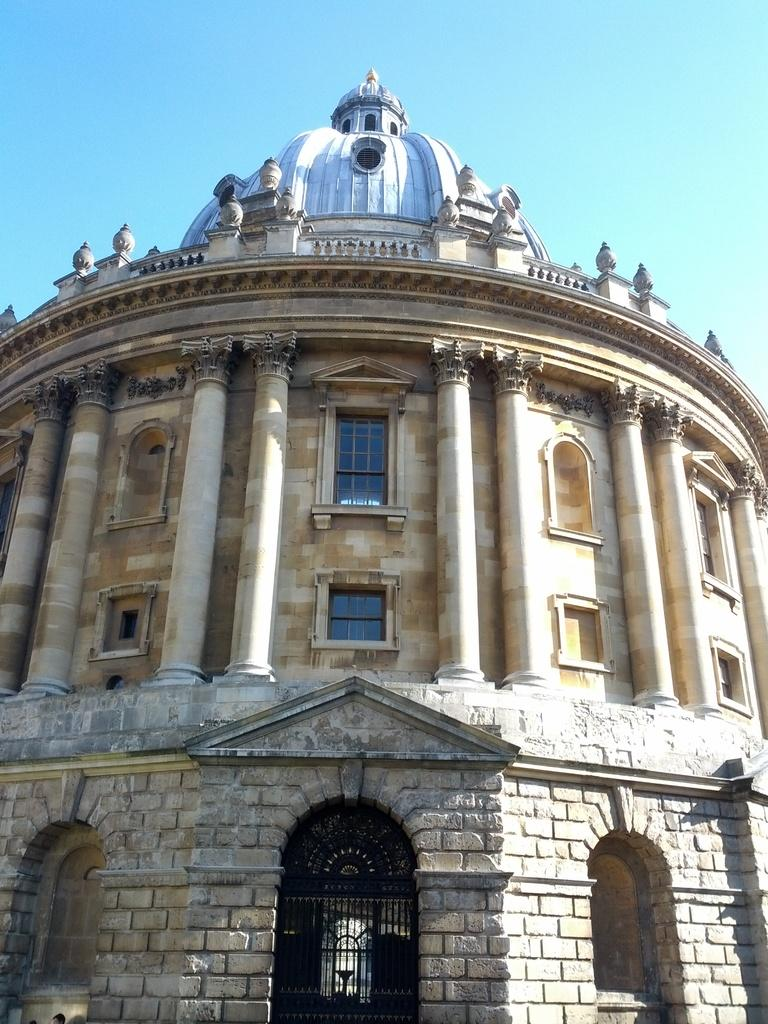What type of structure is present in the picture? There is a building in the picture. What feature of the building is mentioned in the facts? The building has a door, glass windows, and pillars. What else can be seen in the picture besides the building? There is a black gate in the picture. How would you describe the weather based on the image? The sky is clear, suggesting good weather. Can you tell me how many icicles are hanging from the building in the image? There are no icicles present in the image; the sky is clear, indicating no ice formation. What type of pie is being served at the building in the image? There is no pie visible in the image, nor is there any indication of food being served. 